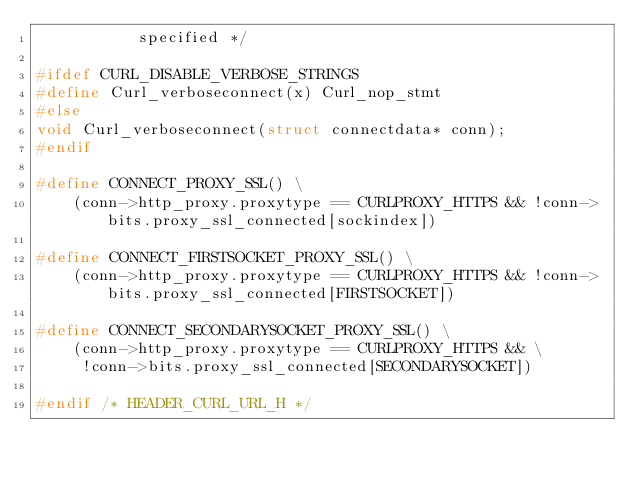<code> <loc_0><loc_0><loc_500><loc_500><_C_>           specified */

#ifdef CURL_DISABLE_VERBOSE_STRINGS
#define Curl_verboseconnect(x) Curl_nop_stmt
#else
void Curl_verboseconnect(struct connectdata* conn);
#endif

#define CONNECT_PROXY_SSL() \
    (conn->http_proxy.proxytype == CURLPROXY_HTTPS && !conn->bits.proxy_ssl_connected[sockindex])

#define CONNECT_FIRSTSOCKET_PROXY_SSL() \
    (conn->http_proxy.proxytype == CURLPROXY_HTTPS && !conn->bits.proxy_ssl_connected[FIRSTSOCKET])

#define CONNECT_SECONDARYSOCKET_PROXY_SSL() \
    (conn->http_proxy.proxytype == CURLPROXY_HTTPS && \
     !conn->bits.proxy_ssl_connected[SECONDARYSOCKET])

#endif /* HEADER_CURL_URL_H */
</code> 